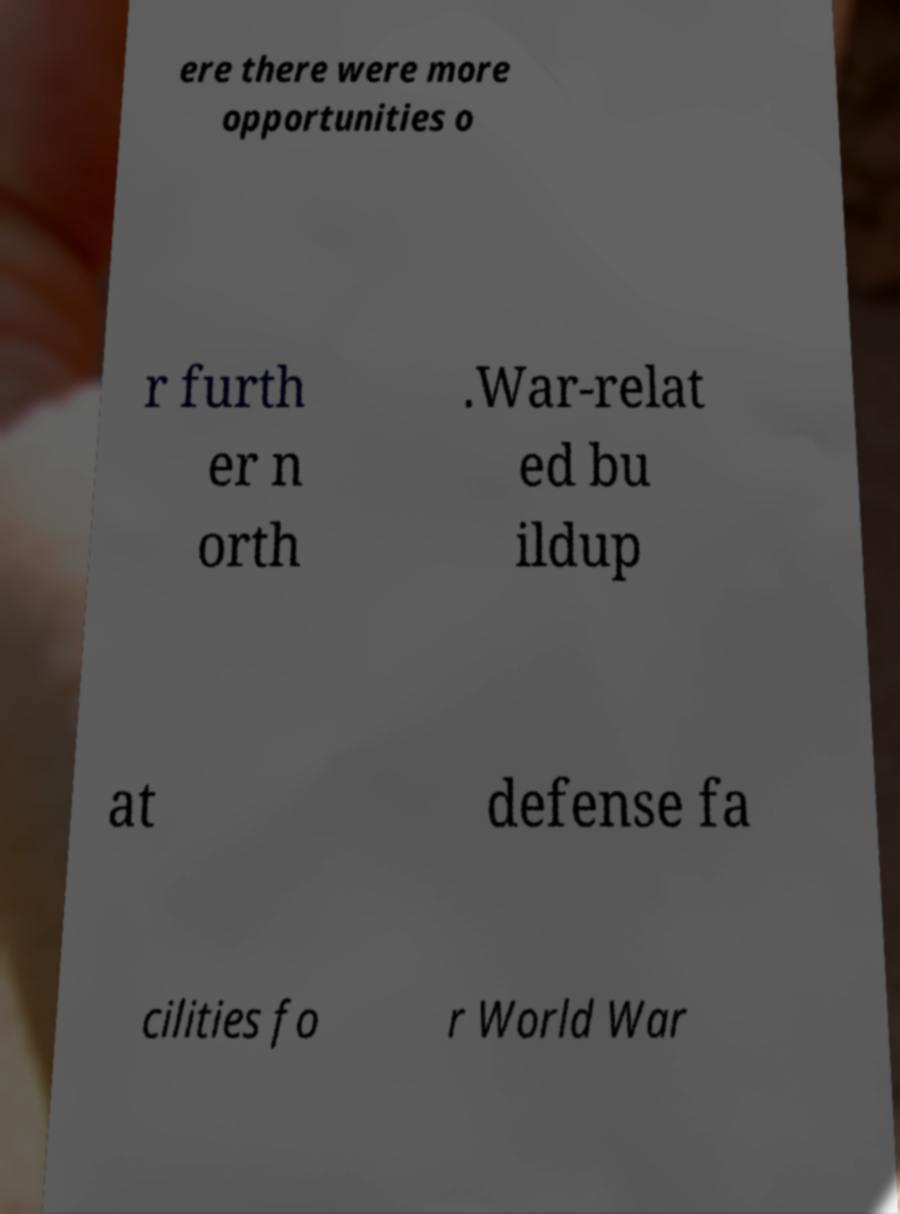There's text embedded in this image that I need extracted. Can you transcribe it verbatim? ere there were more opportunities o r furth er n orth .War-relat ed bu ildup at defense fa cilities fo r World War 